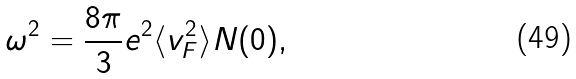<formula> <loc_0><loc_0><loc_500><loc_500>\omega ^ { 2 } = \frac { 8 \pi } { 3 } e ^ { 2 } \langle v ^ { 2 } _ { F } \rangle N ( 0 ) ,</formula> 